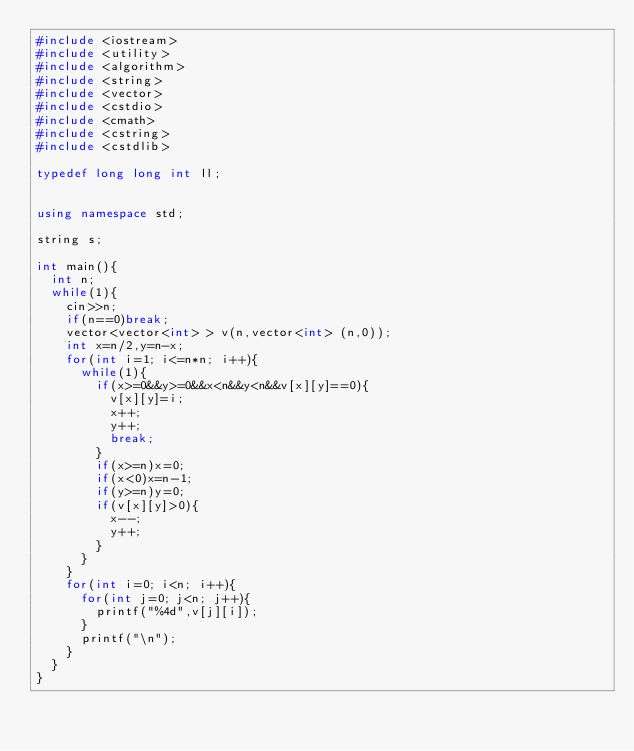Convert code to text. <code><loc_0><loc_0><loc_500><loc_500><_C++_>#include <iostream>
#include <utility>
#include <algorithm>
#include <string>
#include <vector>
#include <cstdio>
#include <cmath>
#include <cstring>
#include <cstdlib>

typedef long long int ll;


using namespace std;

string s;

int main(){
	int n;
	while(1){
		cin>>n;
		if(n==0)break;
		vector<vector<int> > v(n,vector<int> (n,0));
		int x=n/2,y=n-x;
		for(int i=1; i<=n*n; i++){
			while(1){
				if(x>=0&&y>=0&&x<n&&y<n&&v[x][y]==0){
					v[x][y]=i;
					x++;
					y++;
					break;
				}
				if(x>=n)x=0;
				if(x<0)x=n-1;
				if(y>=n)y=0;
				if(v[x][y]>0){
					x--;
					y++;
				}
			}
		}
		for(int i=0; i<n; i++){
			for(int j=0; j<n; j++){
				printf("%4d",v[j][i]);
			}
			printf("\n");
		}
	}
}</code> 